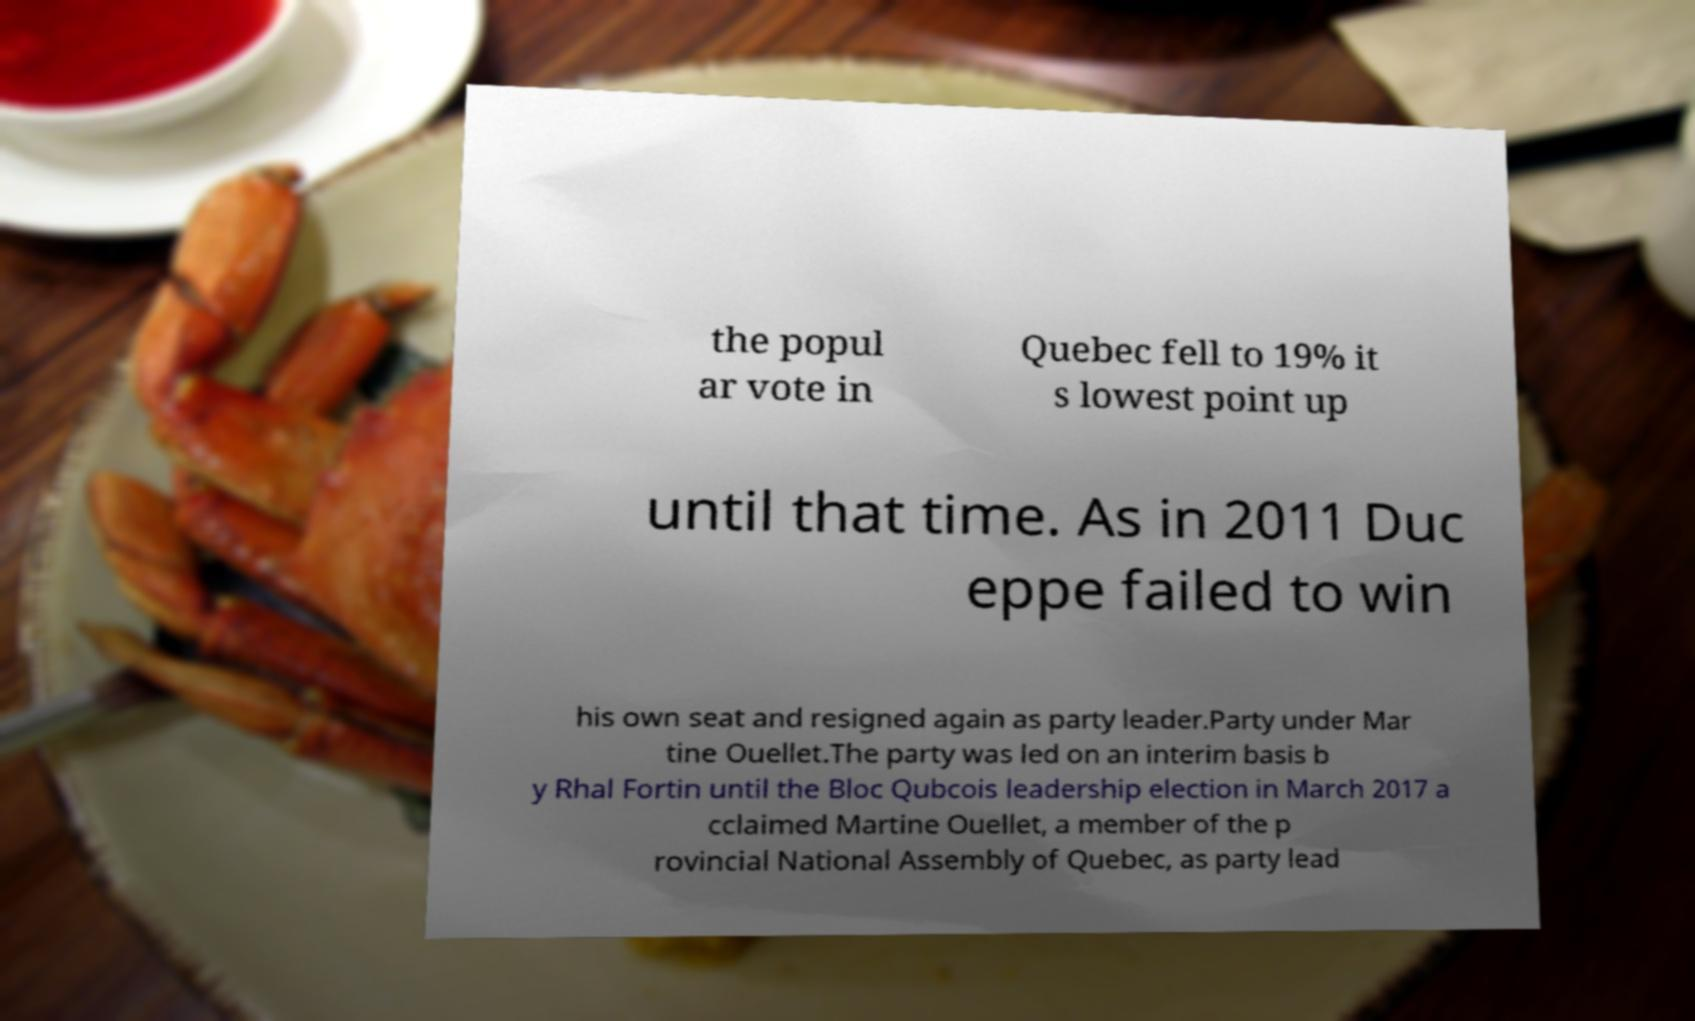Please read and relay the text visible in this image. What does it say? the popul ar vote in Quebec fell to 19% it s lowest point up until that time. As in 2011 Duc eppe failed to win his own seat and resigned again as party leader.Party under Mar tine Ouellet.The party was led on an interim basis b y Rhal Fortin until the Bloc Qubcois leadership election in March 2017 a cclaimed Martine Ouellet, a member of the p rovincial National Assembly of Quebec, as party lead 